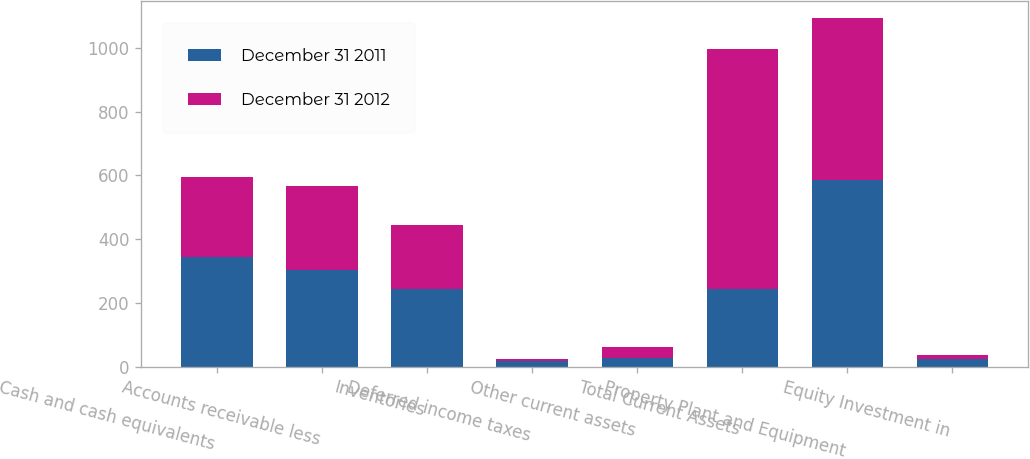Convert chart. <chart><loc_0><loc_0><loc_500><loc_500><stacked_bar_chart><ecel><fcel>Cash and cash equivalents<fcel>Accounts receivable less<fcel>Inventories<fcel>Deferred income taxes<fcel>Other current assets<fcel>Total Current Assets<fcel>Property Plant and Equipment<fcel>Equity Investment in<nl><fcel>December 31 2011<fcel>343<fcel>303.1<fcel>242.2<fcel>17.6<fcel>27.9<fcel>242.2<fcel>586<fcel>23<nl><fcel>December 31 2012<fcel>251.4<fcel>264.6<fcel>200.7<fcel>6<fcel>32.5<fcel>755.2<fcel>506<fcel>12<nl></chart> 